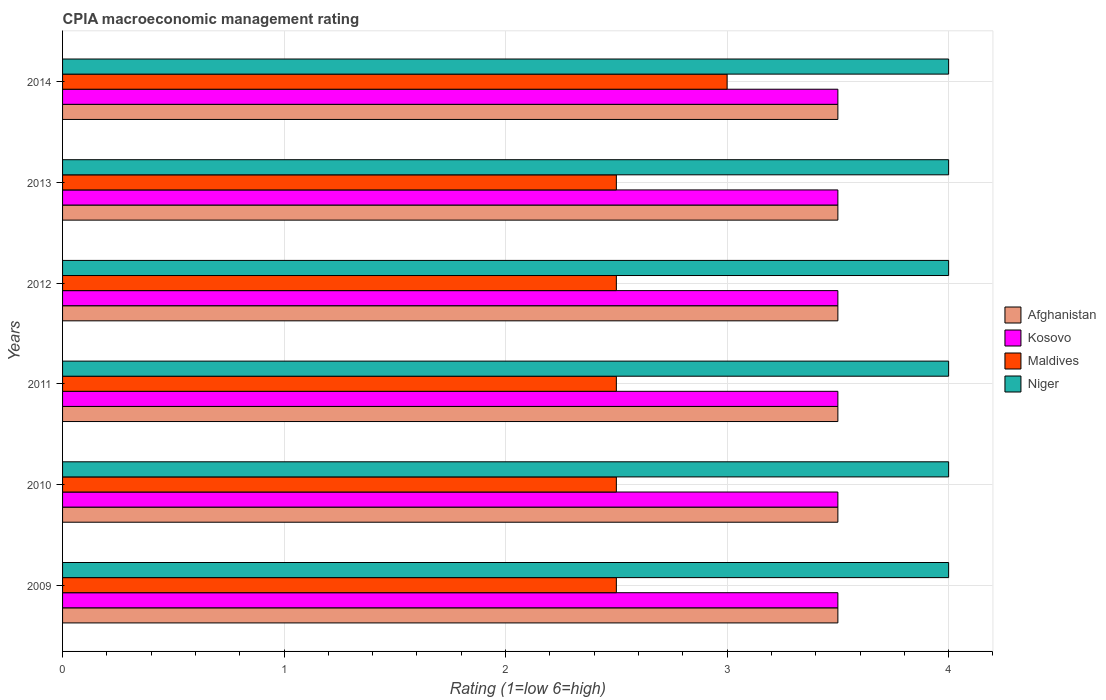Are the number of bars per tick equal to the number of legend labels?
Offer a very short reply. Yes. How many bars are there on the 3rd tick from the top?
Offer a terse response. 4. How many bars are there on the 5th tick from the bottom?
Your answer should be very brief. 4. What is the label of the 6th group of bars from the top?
Your answer should be very brief. 2009. What is the CPIA rating in Maldives in 2012?
Give a very brief answer. 2.5. In which year was the CPIA rating in Kosovo maximum?
Offer a terse response. 2009. What is the difference between the CPIA rating in Niger in 2010 and the CPIA rating in Maldives in 2012?
Ensure brevity in your answer.  1.5. What is the average CPIA rating in Kosovo per year?
Ensure brevity in your answer.  3.5. In how many years, is the CPIA rating in Afghanistan greater than 2.8 ?
Offer a very short reply. 6. What is the ratio of the CPIA rating in Kosovo in 2012 to that in 2014?
Give a very brief answer. 1. What is the difference between the highest and the second highest CPIA rating in Maldives?
Ensure brevity in your answer.  0.5. What is the difference between the highest and the lowest CPIA rating in Maldives?
Give a very brief answer. 0.5. Is the sum of the CPIA rating in Maldives in 2010 and 2011 greater than the maximum CPIA rating in Afghanistan across all years?
Provide a succinct answer. Yes. Is it the case that in every year, the sum of the CPIA rating in Kosovo and CPIA rating in Niger is greater than the sum of CPIA rating in Afghanistan and CPIA rating in Maldives?
Your answer should be compact. Yes. What does the 4th bar from the top in 2012 represents?
Ensure brevity in your answer.  Afghanistan. What does the 2nd bar from the bottom in 2010 represents?
Offer a very short reply. Kosovo. How many bars are there?
Ensure brevity in your answer.  24. Are all the bars in the graph horizontal?
Your response must be concise. Yes. Does the graph contain any zero values?
Your response must be concise. No. Does the graph contain grids?
Give a very brief answer. Yes. Where does the legend appear in the graph?
Offer a very short reply. Center right. What is the title of the graph?
Keep it short and to the point. CPIA macroeconomic management rating. Does "Cabo Verde" appear as one of the legend labels in the graph?
Offer a very short reply. No. What is the label or title of the X-axis?
Make the answer very short. Rating (1=low 6=high). What is the label or title of the Y-axis?
Provide a short and direct response. Years. What is the Rating (1=low 6=high) of Afghanistan in 2009?
Provide a succinct answer. 3.5. What is the Rating (1=low 6=high) of Maldives in 2009?
Your response must be concise. 2.5. What is the Rating (1=low 6=high) of Niger in 2009?
Provide a short and direct response. 4. What is the Rating (1=low 6=high) in Kosovo in 2010?
Make the answer very short. 3.5. What is the Rating (1=low 6=high) in Maldives in 2010?
Provide a succinct answer. 2.5. What is the Rating (1=low 6=high) in Kosovo in 2011?
Your answer should be very brief. 3.5. What is the Rating (1=low 6=high) in Maldives in 2011?
Your response must be concise. 2.5. What is the Rating (1=low 6=high) in Maldives in 2012?
Ensure brevity in your answer.  2.5. What is the Rating (1=low 6=high) in Maldives in 2013?
Give a very brief answer. 2.5. What is the Rating (1=low 6=high) in Niger in 2013?
Ensure brevity in your answer.  4. What is the Rating (1=low 6=high) of Afghanistan in 2014?
Make the answer very short. 3.5. What is the Rating (1=low 6=high) of Niger in 2014?
Offer a terse response. 4. Across all years, what is the maximum Rating (1=low 6=high) in Maldives?
Offer a very short reply. 3. Across all years, what is the minimum Rating (1=low 6=high) of Maldives?
Provide a short and direct response. 2.5. What is the total Rating (1=low 6=high) in Kosovo in the graph?
Provide a succinct answer. 21. What is the difference between the Rating (1=low 6=high) of Afghanistan in 2009 and that in 2010?
Provide a succinct answer. 0. What is the difference between the Rating (1=low 6=high) of Kosovo in 2009 and that in 2010?
Keep it short and to the point. 0. What is the difference between the Rating (1=low 6=high) in Maldives in 2009 and that in 2010?
Offer a very short reply. 0. What is the difference between the Rating (1=low 6=high) in Niger in 2009 and that in 2010?
Your response must be concise. 0. What is the difference between the Rating (1=low 6=high) of Niger in 2009 and that in 2011?
Your answer should be very brief. 0. What is the difference between the Rating (1=low 6=high) in Kosovo in 2009 and that in 2012?
Make the answer very short. 0. What is the difference between the Rating (1=low 6=high) of Maldives in 2009 and that in 2012?
Ensure brevity in your answer.  0. What is the difference between the Rating (1=low 6=high) of Afghanistan in 2009 and that in 2013?
Give a very brief answer. 0. What is the difference between the Rating (1=low 6=high) of Kosovo in 2009 and that in 2014?
Provide a short and direct response. 0. What is the difference between the Rating (1=low 6=high) of Maldives in 2009 and that in 2014?
Provide a short and direct response. -0.5. What is the difference between the Rating (1=low 6=high) of Niger in 2009 and that in 2014?
Offer a very short reply. 0. What is the difference between the Rating (1=low 6=high) in Afghanistan in 2010 and that in 2011?
Keep it short and to the point. 0. What is the difference between the Rating (1=low 6=high) of Maldives in 2010 and that in 2011?
Your answer should be very brief. 0. What is the difference between the Rating (1=low 6=high) in Niger in 2010 and that in 2011?
Keep it short and to the point. 0. What is the difference between the Rating (1=low 6=high) in Afghanistan in 2010 and that in 2012?
Your response must be concise. 0. What is the difference between the Rating (1=low 6=high) in Kosovo in 2010 and that in 2012?
Offer a very short reply. 0. What is the difference between the Rating (1=low 6=high) of Maldives in 2010 and that in 2012?
Offer a very short reply. 0. What is the difference between the Rating (1=low 6=high) in Kosovo in 2010 and that in 2013?
Ensure brevity in your answer.  0. What is the difference between the Rating (1=low 6=high) of Niger in 2010 and that in 2013?
Give a very brief answer. 0. What is the difference between the Rating (1=low 6=high) of Afghanistan in 2010 and that in 2014?
Keep it short and to the point. 0. What is the difference between the Rating (1=low 6=high) in Kosovo in 2010 and that in 2014?
Provide a succinct answer. 0. What is the difference between the Rating (1=low 6=high) in Maldives in 2010 and that in 2014?
Make the answer very short. -0.5. What is the difference between the Rating (1=low 6=high) of Niger in 2010 and that in 2014?
Ensure brevity in your answer.  0. What is the difference between the Rating (1=low 6=high) of Afghanistan in 2011 and that in 2012?
Your answer should be compact. 0. What is the difference between the Rating (1=low 6=high) in Kosovo in 2011 and that in 2012?
Give a very brief answer. 0. What is the difference between the Rating (1=low 6=high) in Maldives in 2011 and that in 2012?
Keep it short and to the point. 0. What is the difference between the Rating (1=low 6=high) in Kosovo in 2011 and that in 2013?
Your answer should be compact. 0. What is the difference between the Rating (1=low 6=high) of Maldives in 2011 and that in 2013?
Offer a terse response. 0. What is the difference between the Rating (1=low 6=high) of Afghanistan in 2011 and that in 2014?
Keep it short and to the point. 0. What is the difference between the Rating (1=low 6=high) of Afghanistan in 2012 and that in 2013?
Keep it short and to the point. 0. What is the difference between the Rating (1=low 6=high) in Maldives in 2012 and that in 2013?
Offer a terse response. 0. What is the difference between the Rating (1=low 6=high) in Niger in 2012 and that in 2013?
Your response must be concise. 0. What is the difference between the Rating (1=low 6=high) in Afghanistan in 2012 and that in 2014?
Offer a terse response. 0. What is the difference between the Rating (1=low 6=high) of Niger in 2012 and that in 2014?
Your response must be concise. 0. What is the difference between the Rating (1=low 6=high) of Maldives in 2013 and that in 2014?
Your response must be concise. -0.5. What is the difference between the Rating (1=low 6=high) in Niger in 2013 and that in 2014?
Give a very brief answer. 0. What is the difference between the Rating (1=low 6=high) in Afghanistan in 2009 and the Rating (1=low 6=high) in Kosovo in 2010?
Offer a terse response. 0. What is the difference between the Rating (1=low 6=high) of Kosovo in 2009 and the Rating (1=low 6=high) of Niger in 2010?
Make the answer very short. -0.5. What is the difference between the Rating (1=low 6=high) in Maldives in 2009 and the Rating (1=low 6=high) in Niger in 2010?
Provide a short and direct response. -1.5. What is the difference between the Rating (1=low 6=high) in Afghanistan in 2009 and the Rating (1=low 6=high) in Niger in 2011?
Provide a succinct answer. -0.5. What is the difference between the Rating (1=low 6=high) of Maldives in 2009 and the Rating (1=low 6=high) of Niger in 2011?
Offer a terse response. -1.5. What is the difference between the Rating (1=low 6=high) of Afghanistan in 2009 and the Rating (1=low 6=high) of Kosovo in 2012?
Keep it short and to the point. 0. What is the difference between the Rating (1=low 6=high) in Afghanistan in 2009 and the Rating (1=low 6=high) in Maldives in 2012?
Provide a succinct answer. 1. What is the difference between the Rating (1=low 6=high) in Kosovo in 2009 and the Rating (1=low 6=high) in Maldives in 2012?
Offer a terse response. 1. What is the difference between the Rating (1=low 6=high) in Kosovo in 2009 and the Rating (1=low 6=high) in Niger in 2012?
Provide a succinct answer. -0.5. What is the difference between the Rating (1=low 6=high) of Afghanistan in 2009 and the Rating (1=low 6=high) of Kosovo in 2013?
Your answer should be compact. 0. What is the difference between the Rating (1=low 6=high) of Kosovo in 2009 and the Rating (1=low 6=high) of Niger in 2013?
Your response must be concise. -0.5. What is the difference between the Rating (1=low 6=high) in Afghanistan in 2009 and the Rating (1=low 6=high) in Niger in 2014?
Offer a terse response. -0.5. What is the difference between the Rating (1=low 6=high) in Afghanistan in 2010 and the Rating (1=low 6=high) in Kosovo in 2011?
Make the answer very short. 0. What is the difference between the Rating (1=low 6=high) of Kosovo in 2010 and the Rating (1=low 6=high) of Maldives in 2011?
Provide a succinct answer. 1. What is the difference between the Rating (1=low 6=high) in Afghanistan in 2010 and the Rating (1=low 6=high) in Kosovo in 2012?
Give a very brief answer. 0. What is the difference between the Rating (1=low 6=high) in Afghanistan in 2010 and the Rating (1=low 6=high) in Maldives in 2012?
Your answer should be compact. 1. What is the difference between the Rating (1=low 6=high) of Afghanistan in 2010 and the Rating (1=low 6=high) of Niger in 2012?
Give a very brief answer. -0.5. What is the difference between the Rating (1=low 6=high) in Afghanistan in 2010 and the Rating (1=low 6=high) in Kosovo in 2013?
Keep it short and to the point. 0. What is the difference between the Rating (1=low 6=high) of Afghanistan in 2010 and the Rating (1=low 6=high) of Maldives in 2013?
Ensure brevity in your answer.  1. What is the difference between the Rating (1=low 6=high) in Afghanistan in 2010 and the Rating (1=low 6=high) in Niger in 2013?
Offer a terse response. -0.5. What is the difference between the Rating (1=low 6=high) in Kosovo in 2010 and the Rating (1=low 6=high) in Maldives in 2013?
Offer a very short reply. 1. What is the difference between the Rating (1=low 6=high) of Kosovo in 2010 and the Rating (1=low 6=high) of Niger in 2013?
Give a very brief answer. -0.5. What is the difference between the Rating (1=low 6=high) in Afghanistan in 2010 and the Rating (1=low 6=high) in Kosovo in 2014?
Your answer should be compact. 0. What is the difference between the Rating (1=low 6=high) of Afghanistan in 2010 and the Rating (1=low 6=high) of Maldives in 2014?
Your answer should be very brief. 0.5. What is the difference between the Rating (1=low 6=high) in Kosovo in 2010 and the Rating (1=low 6=high) in Maldives in 2014?
Give a very brief answer. 0.5. What is the difference between the Rating (1=low 6=high) in Kosovo in 2010 and the Rating (1=low 6=high) in Niger in 2014?
Provide a short and direct response. -0.5. What is the difference between the Rating (1=low 6=high) in Maldives in 2010 and the Rating (1=low 6=high) in Niger in 2014?
Your response must be concise. -1.5. What is the difference between the Rating (1=low 6=high) in Afghanistan in 2011 and the Rating (1=low 6=high) in Maldives in 2012?
Your answer should be compact. 1. What is the difference between the Rating (1=low 6=high) in Kosovo in 2011 and the Rating (1=low 6=high) in Niger in 2012?
Make the answer very short. -0.5. What is the difference between the Rating (1=low 6=high) of Maldives in 2011 and the Rating (1=low 6=high) of Niger in 2012?
Offer a very short reply. -1.5. What is the difference between the Rating (1=low 6=high) in Afghanistan in 2011 and the Rating (1=low 6=high) in Niger in 2013?
Provide a succinct answer. -0.5. What is the difference between the Rating (1=low 6=high) of Maldives in 2011 and the Rating (1=low 6=high) of Niger in 2013?
Provide a succinct answer. -1.5. What is the difference between the Rating (1=low 6=high) in Afghanistan in 2011 and the Rating (1=low 6=high) in Kosovo in 2014?
Make the answer very short. 0. What is the difference between the Rating (1=low 6=high) in Afghanistan in 2011 and the Rating (1=low 6=high) in Maldives in 2014?
Your answer should be very brief. 0.5. What is the difference between the Rating (1=low 6=high) of Kosovo in 2011 and the Rating (1=low 6=high) of Maldives in 2014?
Provide a short and direct response. 0.5. What is the difference between the Rating (1=low 6=high) in Kosovo in 2011 and the Rating (1=low 6=high) in Niger in 2014?
Your response must be concise. -0.5. What is the difference between the Rating (1=low 6=high) in Maldives in 2011 and the Rating (1=low 6=high) in Niger in 2014?
Ensure brevity in your answer.  -1.5. What is the difference between the Rating (1=low 6=high) of Afghanistan in 2012 and the Rating (1=low 6=high) of Kosovo in 2013?
Provide a short and direct response. 0. What is the difference between the Rating (1=low 6=high) in Afghanistan in 2012 and the Rating (1=low 6=high) in Niger in 2013?
Provide a short and direct response. -0.5. What is the difference between the Rating (1=low 6=high) in Kosovo in 2012 and the Rating (1=low 6=high) in Maldives in 2013?
Ensure brevity in your answer.  1. What is the difference between the Rating (1=low 6=high) of Kosovo in 2012 and the Rating (1=low 6=high) of Niger in 2013?
Your answer should be compact. -0.5. What is the difference between the Rating (1=low 6=high) in Afghanistan in 2012 and the Rating (1=low 6=high) in Kosovo in 2014?
Your response must be concise. 0. What is the difference between the Rating (1=low 6=high) in Afghanistan in 2012 and the Rating (1=low 6=high) in Niger in 2014?
Your response must be concise. -0.5. What is the difference between the Rating (1=low 6=high) in Kosovo in 2012 and the Rating (1=low 6=high) in Maldives in 2014?
Your response must be concise. 0.5. What is the difference between the Rating (1=low 6=high) in Kosovo in 2012 and the Rating (1=low 6=high) in Niger in 2014?
Make the answer very short. -0.5. What is the difference between the Rating (1=low 6=high) of Maldives in 2012 and the Rating (1=low 6=high) of Niger in 2014?
Your answer should be very brief. -1.5. What is the difference between the Rating (1=low 6=high) in Afghanistan in 2013 and the Rating (1=low 6=high) in Kosovo in 2014?
Your response must be concise. 0. What is the difference between the Rating (1=low 6=high) in Afghanistan in 2013 and the Rating (1=low 6=high) in Maldives in 2014?
Make the answer very short. 0.5. What is the difference between the Rating (1=low 6=high) of Kosovo in 2013 and the Rating (1=low 6=high) of Maldives in 2014?
Your answer should be very brief. 0.5. What is the difference between the Rating (1=low 6=high) of Kosovo in 2013 and the Rating (1=low 6=high) of Niger in 2014?
Provide a short and direct response. -0.5. What is the difference between the Rating (1=low 6=high) in Maldives in 2013 and the Rating (1=low 6=high) in Niger in 2014?
Your answer should be compact. -1.5. What is the average Rating (1=low 6=high) of Afghanistan per year?
Offer a very short reply. 3.5. What is the average Rating (1=low 6=high) in Kosovo per year?
Provide a succinct answer. 3.5. What is the average Rating (1=low 6=high) of Maldives per year?
Your answer should be compact. 2.58. What is the average Rating (1=low 6=high) in Niger per year?
Give a very brief answer. 4. In the year 2009, what is the difference between the Rating (1=low 6=high) of Afghanistan and Rating (1=low 6=high) of Kosovo?
Offer a terse response. 0. In the year 2009, what is the difference between the Rating (1=low 6=high) of Kosovo and Rating (1=low 6=high) of Niger?
Make the answer very short. -0.5. In the year 2010, what is the difference between the Rating (1=low 6=high) in Afghanistan and Rating (1=low 6=high) in Maldives?
Your answer should be very brief. 1. In the year 2010, what is the difference between the Rating (1=low 6=high) of Afghanistan and Rating (1=low 6=high) of Niger?
Offer a very short reply. -0.5. In the year 2010, what is the difference between the Rating (1=low 6=high) of Maldives and Rating (1=low 6=high) of Niger?
Your response must be concise. -1.5. In the year 2011, what is the difference between the Rating (1=low 6=high) of Afghanistan and Rating (1=low 6=high) of Kosovo?
Keep it short and to the point. 0. In the year 2011, what is the difference between the Rating (1=low 6=high) of Afghanistan and Rating (1=low 6=high) of Maldives?
Your answer should be very brief. 1. In the year 2012, what is the difference between the Rating (1=low 6=high) of Kosovo and Rating (1=low 6=high) of Maldives?
Your answer should be compact. 1. In the year 2012, what is the difference between the Rating (1=low 6=high) in Kosovo and Rating (1=low 6=high) in Niger?
Ensure brevity in your answer.  -0.5. In the year 2012, what is the difference between the Rating (1=low 6=high) of Maldives and Rating (1=low 6=high) of Niger?
Provide a succinct answer. -1.5. In the year 2013, what is the difference between the Rating (1=low 6=high) of Afghanistan and Rating (1=low 6=high) of Kosovo?
Offer a very short reply. 0. In the year 2013, what is the difference between the Rating (1=low 6=high) in Kosovo and Rating (1=low 6=high) in Niger?
Make the answer very short. -0.5. In the year 2013, what is the difference between the Rating (1=low 6=high) of Maldives and Rating (1=low 6=high) of Niger?
Your response must be concise. -1.5. In the year 2014, what is the difference between the Rating (1=low 6=high) of Afghanistan and Rating (1=low 6=high) of Kosovo?
Your answer should be very brief. 0. In the year 2014, what is the difference between the Rating (1=low 6=high) of Afghanistan and Rating (1=low 6=high) of Niger?
Your answer should be compact. -0.5. In the year 2014, what is the difference between the Rating (1=low 6=high) in Kosovo and Rating (1=low 6=high) in Maldives?
Ensure brevity in your answer.  0.5. In the year 2014, what is the difference between the Rating (1=low 6=high) in Kosovo and Rating (1=low 6=high) in Niger?
Make the answer very short. -0.5. What is the ratio of the Rating (1=low 6=high) in Maldives in 2009 to that in 2010?
Your answer should be compact. 1. What is the ratio of the Rating (1=low 6=high) of Afghanistan in 2009 to that in 2011?
Provide a short and direct response. 1. What is the ratio of the Rating (1=low 6=high) in Kosovo in 2009 to that in 2011?
Provide a short and direct response. 1. What is the ratio of the Rating (1=low 6=high) of Afghanistan in 2009 to that in 2012?
Make the answer very short. 1. What is the ratio of the Rating (1=low 6=high) in Kosovo in 2009 to that in 2012?
Offer a very short reply. 1. What is the ratio of the Rating (1=low 6=high) in Maldives in 2009 to that in 2012?
Offer a very short reply. 1. What is the ratio of the Rating (1=low 6=high) of Afghanistan in 2009 to that in 2013?
Ensure brevity in your answer.  1. What is the ratio of the Rating (1=low 6=high) of Kosovo in 2009 to that in 2013?
Keep it short and to the point. 1. What is the ratio of the Rating (1=low 6=high) of Niger in 2009 to that in 2013?
Keep it short and to the point. 1. What is the ratio of the Rating (1=low 6=high) in Afghanistan in 2009 to that in 2014?
Your response must be concise. 1. What is the ratio of the Rating (1=low 6=high) in Maldives in 2009 to that in 2014?
Your response must be concise. 0.83. What is the ratio of the Rating (1=low 6=high) in Niger in 2009 to that in 2014?
Your response must be concise. 1. What is the ratio of the Rating (1=low 6=high) in Afghanistan in 2010 to that in 2011?
Offer a very short reply. 1. What is the ratio of the Rating (1=low 6=high) in Maldives in 2010 to that in 2011?
Give a very brief answer. 1. What is the ratio of the Rating (1=low 6=high) in Niger in 2010 to that in 2011?
Your answer should be compact. 1. What is the ratio of the Rating (1=low 6=high) of Kosovo in 2010 to that in 2012?
Give a very brief answer. 1. What is the ratio of the Rating (1=low 6=high) in Afghanistan in 2010 to that in 2013?
Offer a terse response. 1. What is the ratio of the Rating (1=low 6=high) in Afghanistan in 2011 to that in 2012?
Give a very brief answer. 1. What is the ratio of the Rating (1=low 6=high) in Kosovo in 2011 to that in 2012?
Ensure brevity in your answer.  1. What is the ratio of the Rating (1=low 6=high) of Niger in 2011 to that in 2012?
Provide a succinct answer. 1. What is the ratio of the Rating (1=low 6=high) in Maldives in 2011 to that in 2013?
Provide a succinct answer. 1. What is the ratio of the Rating (1=low 6=high) of Niger in 2011 to that in 2013?
Your answer should be compact. 1. What is the ratio of the Rating (1=low 6=high) in Afghanistan in 2011 to that in 2014?
Give a very brief answer. 1. What is the ratio of the Rating (1=low 6=high) of Niger in 2012 to that in 2013?
Provide a short and direct response. 1. What is the ratio of the Rating (1=low 6=high) of Afghanistan in 2012 to that in 2014?
Provide a succinct answer. 1. What is the ratio of the Rating (1=low 6=high) in Maldives in 2012 to that in 2014?
Your answer should be very brief. 0.83. What is the ratio of the Rating (1=low 6=high) of Niger in 2012 to that in 2014?
Provide a succinct answer. 1. What is the ratio of the Rating (1=low 6=high) of Niger in 2013 to that in 2014?
Provide a short and direct response. 1. What is the difference between the highest and the second highest Rating (1=low 6=high) of Afghanistan?
Give a very brief answer. 0. What is the difference between the highest and the second highest Rating (1=low 6=high) in Kosovo?
Your response must be concise. 0. What is the difference between the highest and the second highest Rating (1=low 6=high) in Maldives?
Offer a terse response. 0.5. 